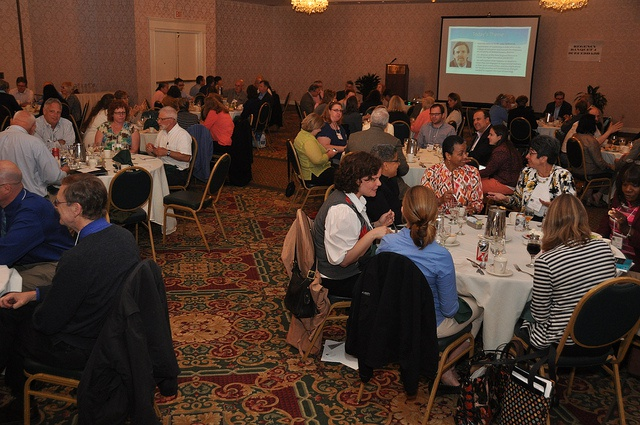Describe the objects in this image and their specific colors. I can see people in maroon, black, and brown tones, people in maroon, black, and brown tones, chair in maroon, black, and brown tones, chair in maroon, black, and gray tones, and people in maroon, black, gray, and darkgray tones in this image. 